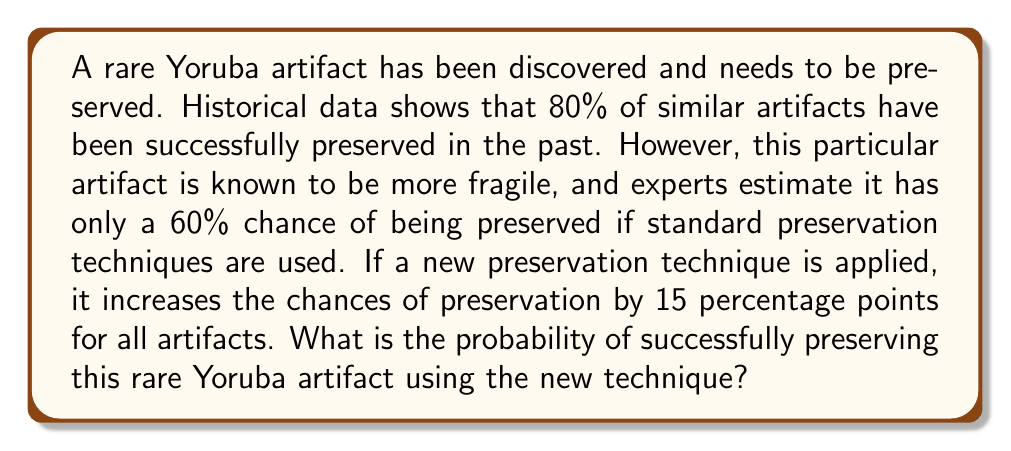Teach me how to tackle this problem. To solve this problem, we'll use Bayesian reasoning and the given information:

1. Let's define our events:
   A: The artifact is successfully preserved
   B: The artifact is more fragile

2. Given probabilities:
   P(A) = 0.80 (prior probability based on historical data)
   P(A|B) = 0.60 (probability of preservation given it's more fragile)
   P(A|B) + 0.15 = 0.75 (probability of preservation with new technique)

3. We want to find P(A|B) with the new technique, which is 0.75.

4. To verify this using Bayes' theorem:

   $$P(A|B) = \frac{P(B|A) \cdot P(A)}{P(B)}$$

   However, we don't need to use this formula directly in this case, as we're given the conditional probability P(A|B) and asked to add 15 percentage points to it.

5. The final probability is simply:

   $$P(\text{preservation with new technique}) = P(A|B) + 0.15 = 0.60 + 0.15 = 0.75$$

Therefore, the probability of successfully preserving this rare Yoruba artifact using the new technique is 0.75 or 75%.
Answer: 0.75 or 75% 